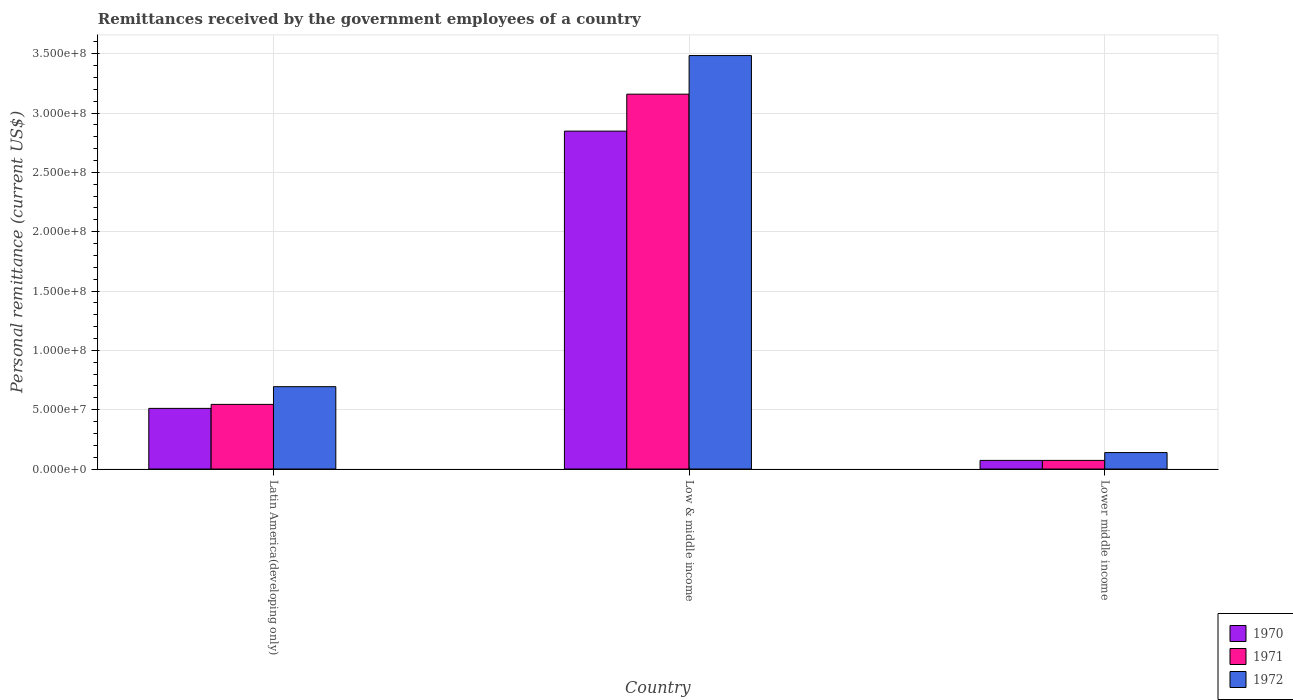How many different coloured bars are there?
Your answer should be compact. 3. How many bars are there on the 1st tick from the right?
Offer a terse response. 3. What is the label of the 3rd group of bars from the left?
Your response must be concise. Lower middle income. What is the remittances received by the government employees in 1970 in Lower middle income?
Give a very brief answer. 7.26e+06. Across all countries, what is the maximum remittances received by the government employees in 1971?
Provide a succinct answer. 3.16e+08. Across all countries, what is the minimum remittances received by the government employees in 1970?
Your answer should be very brief. 7.26e+06. In which country was the remittances received by the government employees in 1970 maximum?
Offer a terse response. Low & middle income. In which country was the remittances received by the government employees in 1972 minimum?
Your answer should be very brief. Lower middle income. What is the total remittances received by the government employees in 1971 in the graph?
Your response must be concise. 3.78e+08. What is the difference between the remittances received by the government employees in 1971 in Latin America(developing only) and that in Lower middle income?
Give a very brief answer. 4.72e+07. What is the difference between the remittances received by the government employees in 1971 in Low & middle income and the remittances received by the government employees in 1972 in Latin America(developing only)?
Ensure brevity in your answer.  2.47e+08. What is the average remittances received by the government employees in 1972 per country?
Ensure brevity in your answer.  1.44e+08. What is the difference between the remittances received by the government employees of/in 1971 and remittances received by the government employees of/in 1972 in Latin America(developing only)?
Provide a succinct answer. -1.49e+07. What is the ratio of the remittances received by the government employees in 1971 in Latin America(developing only) to that in Low & middle income?
Give a very brief answer. 0.17. Is the remittances received by the government employees in 1971 in Latin America(developing only) less than that in Lower middle income?
Your answer should be compact. No. Is the difference between the remittances received by the government employees in 1971 in Low & middle income and Lower middle income greater than the difference between the remittances received by the government employees in 1972 in Low & middle income and Lower middle income?
Offer a terse response. No. What is the difference between the highest and the second highest remittances received by the government employees in 1971?
Offer a very short reply. -3.09e+08. What is the difference between the highest and the lowest remittances received by the government employees in 1972?
Give a very brief answer. 3.35e+08. What does the 2nd bar from the right in Low & middle income represents?
Keep it short and to the point. 1971. Is it the case that in every country, the sum of the remittances received by the government employees in 1971 and remittances received by the government employees in 1970 is greater than the remittances received by the government employees in 1972?
Make the answer very short. Yes. What is the difference between two consecutive major ticks on the Y-axis?
Provide a short and direct response. 5.00e+07. Does the graph contain grids?
Your response must be concise. Yes. What is the title of the graph?
Your answer should be very brief. Remittances received by the government employees of a country. Does "1981" appear as one of the legend labels in the graph?
Provide a succinct answer. No. What is the label or title of the X-axis?
Offer a very short reply. Country. What is the label or title of the Y-axis?
Your answer should be very brief. Personal remittance (current US$). What is the Personal remittance (current US$) in 1970 in Latin America(developing only)?
Make the answer very short. 5.11e+07. What is the Personal remittance (current US$) of 1971 in Latin America(developing only)?
Offer a very short reply. 5.45e+07. What is the Personal remittance (current US$) of 1972 in Latin America(developing only)?
Offer a very short reply. 6.94e+07. What is the Personal remittance (current US$) in 1970 in Low & middle income?
Make the answer very short. 2.85e+08. What is the Personal remittance (current US$) of 1971 in Low & middle income?
Your answer should be very brief. 3.16e+08. What is the Personal remittance (current US$) in 1972 in Low & middle income?
Your answer should be compact. 3.48e+08. What is the Personal remittance (current US$) in 1970 in Lower middle income?
Provide a succinct answer. 7.26e+06. What is the Personal remittance (current US$) of 1971 in Lower middle income?
Your response must be concise. 7.26e+06. What is the Personal remittance (current US$) in 1972 in Lower middle income?
Provide a short and direct response. 1.39e+07. Across all countries, what is the maximum Personal remittance (current US$) in 1970?
Give a very brief answer. 2.85e+08. Across all countries, what is the maximum Personal remittance (current US$) in 1971?
Provide a short and direct response. 3.16e+08. Across all countries, what is the maximum Personal remittance (current US$) in 1972?
Ensure brevity in your answer.  3.48e+08. Across all countries, what is the minimum Personal remittance (current US$) of 1970?
Your response must be concise. 7.26e+06. Across all countries, what is the minimum Personal remittance (current US$) of 1971?
Offer a terse response. 7.26e+06. Across all countries, what is the minimum Personal remittance (current US$) of 1972?
Your answer should be very brief. 1.39e+07. What is the total Personal remittance (current US$) in 1970 in the graph?
Keep it short and to the point. 3.43e+08. What is the total Personal remittance (current US$) in 1971 in the graph?
Provide a short and direct response. 3.78e+08. What is the total Personal remittance (current US$) in 1972 in the graph?
Keep it short and to the point. 4.32e+08. What is the difference between the Personal remittance (current US$) in 1970 in Latin America(developing only) and that in Low & middle income?
Make the answer very short. -2.34e+08. What is the difference between the Personal remittance (current US$) of 1971 in Latin America(developing only) and that in Low & middle income?
Give a very brief answer. -2.61e+08. What is the difference between the Personal remittance (current US$) of 1972 in Latin America(developing only) and that in Low & middle income?
Your response must be concise. -2.79e+08. What is the difference between the Personal remittance (current US$) of 1970 in Latin America(developing only) and that in Lower middle income?
Offer a very short reply. 4.38e+07. What is the difference between the Personal remittance (current US$) in 1971 in Latin America(developing only) and that in Lower middle income?
Make the answer very short. 4.72e+07. What is the difference between the Personal remittance (current US$) of 1972 in Latin America(developing only) and that in Lower middle income?
Keep it short and to the point. 5.55e+07. What is the difference between the Personal remittance (current US$) of 1970 in Low & middle income and that in Lower middle income?
Your answer should be compact. 2.77e+08. What is the difference between the Personal remittance (current US$) of 1971 in Low & middle income and that in Lower middle income?
Give a very brief answer. 3.09e+08. What is the difference between the Personal remittance (current US$) in 1972 in Low & middle income and that in Lower middle income?
Your answer should be compact. 3.35e+08. What is the difference between the Personal remittance (current US$) of 1970 in Latin America(developing only) and the Personal remittance (current US$) of 1971 in Low & middle income?
Your response must be concise. -2.65e+08. What is the difference between the Personal remittance (current US$) of 1970 in Latin America(developing only) and the Personal remittance (current US$) of 1972 in Low & middle income?
Provide a succinct answer. -2.97e+08. What is the difference between the Personal remittance (current US$) in 1971 in Latin America(developing only) and the Personal remittance (current US$) in 1972 in Low & middle income?
Keep it short and to the point. -2.94e+08. What is the difference between the Personal remittance (current US$) of 1970 in Latin America(developing only) and the Personal remittance (current US$) of 1971 in Lower middle income?
Offer a terse response. 4.38e+07. What is the difference between the Personal remittance (current US$) of 1970 in Latin America(developing only) and the Personal remittance (current US$) of 1972 in Lower middle income?
Keep it short and to the point. 3.72e+07. What is the difference between the Personal remittance (current US$) of 1971 in Latin America(developing only) and the Personal remittance (current US$) of 1972 in Lower middle income?
Make the answer very short. 4.06e+07. What is the difference between the Personal remittance (current US$) of 1970 in Low & middle income and the Personal remittance (current US$) of 1971 in Lower middle income?
Offer a very short reply. 2.77e+08. What is the difference between the Personal remittance (current US$) in 1970 in Low & middle income and the Personal remittance (current US$) in 1972 in Lower middle income?
Offer a very short reply. 2.71e+08. What is the difference between the Personal remittance (current US$) in 1971 in Low & middle income and the Personal remittance (current US$) in 1972 in Lower middle income?
Offer a very short reply. 3.02e+08. What is the average Personal remittance (current US$) of 1970 per country?
Your answer should be compact. 1.14e+08. What is the average Personal remittance (current US$) of 1971 per country?
Provide a short and direct response. 1.26e+08. What is the average Personal remittance (current US$) in 1972 per country?
Make the answer very short. 1.44e+08. What is the difference between the Personal remittance (current US$) of 1970 and Personal remittance (current US$) of 1971 in Latin America(developing only)?
Offer a terse response. -3.37e+06. What is the difference between the Personal remittance (current US$) of 1970 and Personal remittance (current US$) of 1972 in Latin America(developing only)?
Provide a succinct answer. -1.83e+07. What is the difference between the Personal remittance (current US$) of 1971 and Personal remittance (current US$) of 1972 in Latin America(developing only)?
Your answer should be compact. -1.49e+07. What is the difference between the Personal remittance (current US$) of 1970 and Personal remittance (current US$) of 1971 in Low & middle income?
Provide a short and direct response. -3.11e+07. What is the difference between the Personal remittance (current US$) in 1970 and Personal remittance (current US$) in 1972 in Low & middle income?
Give a very brief answer. -6.37e+07. What is the difference between the Personal remittance (current US$) of 1971 and Personal remittance (current US$) of 1972 in Low & middle income?
Ensure brevity in your answer.  -3.25e+07. What is the difference between the Personal remittance (current US$) of 1970 and Personal remittance (current US$) of 1971 in Lower middle income?
Give a very brief answer. 0. What is the difference between the Personal remittance (current US$) of 1970 and Personal remittance (current US$) of 1972 in Lower middle income?
Your answer should be compact. -6.60e+06. What is the difference between the Personal remittance (current US$) of 1971 and Personal remittance (current US$) of 1972 in Lower middle income?
Keep it short and to the point. -6.60e+06. What is the ratio of the Personal remittance (current US$) in 1970 in Latin America(developing only) to that in Low & middle income?
Provide a short and direct response. 0.18. What is the ratio of the Personal remittance (current US$) of 1971 in Latin America(developing only) to that in Low & middle income?
Ensure brevity in your answer.  0.17. What is the ratio of the Personal remittance (current US$) of 1972 in Latin America(developing only) to that in Low & middle income?
Offer a terse response. 0.2. What is the ratio of the Personal remittance (current US$) in 1970 in Latin America(developing only) to that in Lower middle income?
Offer a very short reply. 7.04. What is the ratio of the Personal remittance (current US$) in 1971 in Latin America(developing only) to that in Lower middle income?
Provide a succinct answer. 7.5. What is the ratio of the Personal remittance (current US$) in 1972 in Latin America(developing only) to that in Lower middle income?
Ensure brevity in your answer.  5.01. What is the ratio of the Personal remittance (current US$) of 1970 in Low & middle income to that in Lower middle income?
Provide a succinct answer. 39.22. What is the ratio of the Personal remittance (current US$) of 1971 in Low & middle income to that in Lower middle income?
Offer a terse response. 43.51. What is the ratio of the Personal remittance (current US$) of 1972 in Low & middle income to that in Lower middle income?
Offer a terse response. 25.14. What is the difference between the highest and the second highest Personal remittance (current US$) of 1970?
Give a very brief answer. 2.34e+08. What is the difference between the highest and the second highest Personal remittance (current US$) in 1971?
Make the answer very short. 2.61e+08. What is the difference between the highest and the second highest Personal remittance (current US$) of 1972?
Provide a succinct answer. 2.79e+08. What is the difference between the highest and the lowest Personal remittance (current US$) in 1970?
Provide a succinct answer. 2.77e+08. What is the difference between the highest and the lowest Personal remittance (current US$) in 1971?
Your answer should be compact. 3.09e+08. What is the difference between the highest and the lowest Personal remittance (current US$) in 1972?
Give a very brief answer. 3.35e+08. 